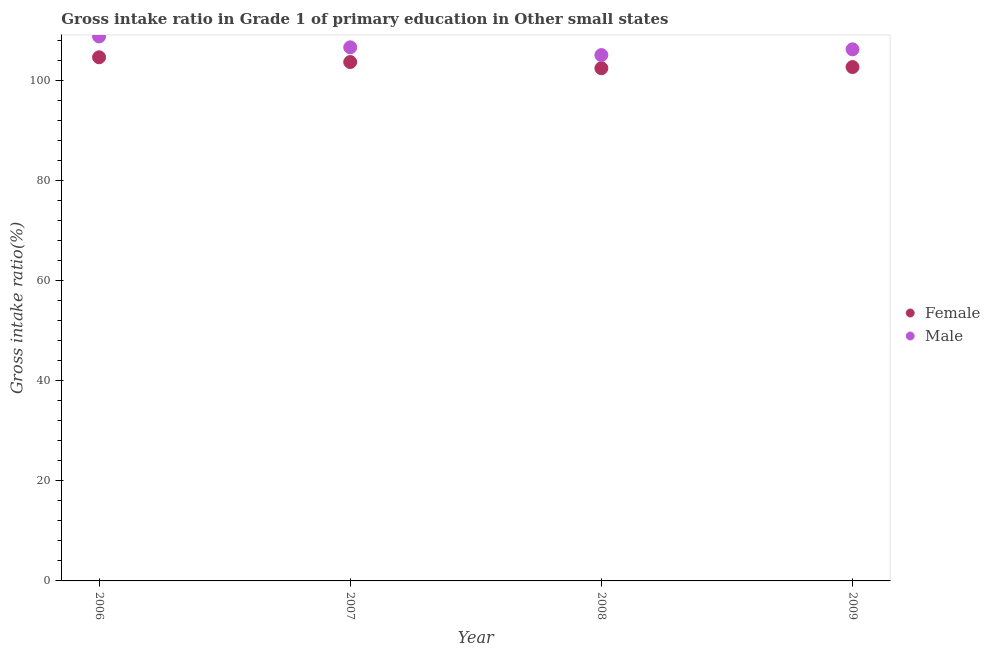How many different coloured dotlines are there?
Make the answer very short. 2. Is the number of dotlines equal to the number of legend labels?
Your answer should be very brief. Yes. What is the gross intake ratio(male) in 2009?
Give a very brief answer. 106.2. Across all years, what is the maximum gross intake ratio(female)?
Provide a succinct answer. 104.61. Across all years, what is the minimum gross intake ratio(female)?
Keep it short and to the point. 102.42. In which year was the gross intake ratio(female) minimum?
Provide a succinct answer. 2008. What is the total gross intake ratio(male) in the graph?
Offer a very short reply. 426.63. What is the difference between the gross intake ratio(female) in 2006 and that in 2009?
Ensure brevity in your answer.  1.95. What is the difference between the gross intake ratio(male) in 2007 and the gross intake ratio(female) in 2009?
Make the answer very short. 3.94. What is the average gross intake ratio(female) per year?
Provide a short and direct response. 103.34. In the year 2007, what is the difference between the gross intake ratio(male) and gross intake ratio(female)?
Give a very brief answer. 2.94. In how many years, is the gross intake ratio(male) greater than 48 %?
Provide a succinct answer. 4. What is the ratio of the gross intake ratio(male) in 2008 to that in 2009?
Give a very brief answer. 0.99. Is the difference between the gross intake ratio(female) in 2007 and 2008 greater than the difference between the gross intake ratio(male) in 2007 and 2008?
Provide a succinct answer. No. What is the difference between the highest and the second highest gross intake ratio(female)?
Your response must be concise. 0.95. What is the difference between the highest and the lowest gross intake ratio(male)?
Provide a succinct answer. 3.72. Is the gross intake ratio(female) strictly less than the gross intake ratio(male) over the years?
Your answer should be compact. Yes. How many dotlines are there?
Make the answer very short. 2. What is the difference between two consecutive major ticks on the Y-axis?
Offer a terse response. 20. Are the values on the major ticks of Y-axis written in scientific E-notation?
Your answer should be compact. No. Does the graph contain any zero values?
Ensure brevity in your answer.  No. Where does the legend appear in the graph?
Give a very brief answer. Center right. How many legend labels are there?
Provide a succinct answer. 2. How are the legend labels stacked?
Keep it short and to the point. Vertical. What is the title of the graph?
Your answer should be very brief. Gross intake ratio in Grade 1 of primary education in Other small states. What is the label or title of the X-axis?
Provide a succinct answer. Year. What is the label or title of the Y-axis?
Your response must be concise. Gross intake ratio(%). What is the Gross intake ratio(%) of Female in 2006?
Offer a very short reply. 104.61. What is the Gross intake ratio(%) of Male in 2006?
Your response must be concise. 108.77. What is the Gross intake ratio(%) of Female in 2007?
Provide a succinct answer. 103.66. What is the Gross intake ratio(%) in Male in 2007?
Your response must be concise. 106.6. What is the Gross intake ratio(%) of Female in 2008?
Provide a succinct answer. 102.42. What is the Gross intake ratio(%) in Male in 2008?
Your response must be concise. 105.05. What is the Gross intake ratio(%) in Female in 2009?
Your answer should be compact. 102.66. What is the Gross intake ratio(%) in Male in 2009?
Make the answer very short. 106.2. Across all years, what is the maximum Gross intake ratio(%) of Female?
Make the answer very short. 104.61. Across all years, what is the maximum Gross intake ratio(%) in Male?
Ensure brevity in your answer.  108.77. Across all years, what is the minimum Gross intake ratio(%) of Female?
Provide a succinct answer. 102.42. Across all years, what is the minimum Gross intake ratio(%) of Male?
Keep it short and to the point. 105.05. What is the total Gross intake ratio(%) in Female in the graph?
Provide a succinct answer. 413.36. What is the total Gross intake ratio(%) of Male in the graph?
Give a very brief answer. 426.63. What is the difference between the Gross intake ratio(%) of Female in 2006 and that in 2007?
Offer a very short reply. 0.95. What is the difference between the Gross intake ratio(%) in Male in 2006 and that in 2007?
Make the answer very short. 2.17. What is the difference between the Gross intake ratio(%) of Female in 2006 and that in 2008?
Offer a terse response. 2.19. What is the difference between the Gross intake ratio(%) of Male in 2006 and that in 2008?
Offer a very short reply. 3.72. What is the difference between the Gross intake ratio(%) of Female in 2006 and that in 2009?
Offer a very short reply. 1.95. What is the difference between the Gross intake ratio(%) in Male in 2006 and that in 2009?
Your response must be concise. 2.57. What is the difference between the Gross intake ratio(%) in Female in 2007 and that in 2008?
Your answer should be compact. 1.24. What is the difference between the Gross intake ratio(%) in Male in 2007 and that in 2008?
Offer a terse response. 1.55. What is the difference between the Gross intake ratio(%) of Male in 2007 and that in 2009?
Give a very brief answer. 0.4. What is the difference between the Gross intake ratio(%) in Female in 2008 and that in 2009?
Offer a terse response. -0.24. What is the difference between the Gross intake ratio(%) of Male in 2008 and that in 2009?
Offer a terse response. -1.15. What is the difference between the Gross intake ratio(%) of Female in 2006 and the Gross intake ratio(%) of Male in 2007?
Offer a very short reply. -1.99. What is the difference between the Gross intake ratio(%) in Female in 2006 and the Gross intake ratio(%) in Male in 2008?
Offer a very short reply. -0.44. What is the difference between the Gross intake ratio(%) in Female in 2006 and the Gross intake ratio(%) in Male in 2009?
Offer a very short reply. -1.59. What is the difference between the Gross intake ratio(%) in Female in 2007 and the Gross intake ratio(%) in Male in 2008?
Your answer should be compact. -1.39. What is the difference between the Gross intake ratio(%) in Female in 2007 and the Gross intake ratio(%) in Male in 2009?
Your answer should be very brief. -2.54. What is the difference between the Gross intake ratio(%) of Female in 2008 and the Gross intake ratio(%) of Male in 2009?
Your answer should be very brief. -3.78. What is the average Gross intake ratio(%) of Female per year?
Ensure brevity in your answer.  103.34. What is the average Gross intake ratio(%) of Male per year?
Provide a succinct answer. 106.66. In the year 2006, what is the difference between the Gross intake ratio(%) in Female and Gross intake ratio(%) in Male?
Give a very brief answer. -4.16. In the year 2007, what is the difference between the Gross intake ratio(%) in Female and Gross intake ratio(%) in Male?
Make the answer very short. -2.94. In the year 2008, what is the difference between the Gross intake ratio(%) of Female and Gross intake ratio(%) of Male?
Offer a very short reply. -2.63. In the year 2009, what is the difference between the Gross intake ratio(%) of Female and Gross intake ratio(%) of Male?
Your answer should be compact. -3.54. What is the ratio of the Gross intake ratio(%) of Female in 2006 to that in 2007?
Offer a very short reply. 1.01. What is the ratio of the Gross intake ratio(%) in Male in 2006 to that in 2007?
Ensure brevity in your answer.  1.02. What is the ratio of the Gross intake ratio(%) in Female in 2006 to that in 2008?
Keep it short and to the point. 1.02. What is the ratio of the Gross intake ratio(%) in Male in 2006 to that in 2008?
Your answer should be very brief. 1.04. What is the ratio of the Gross intake ratio(%) in Female in 2006 to that in 2009?
Keep it short and to the point. 1.02. What is the ratio of the Gross intake ratio(%) in Male in 2006 to that in 2009?
Make the answer very short. 1.02. What is the ratio of the Gross intake ratio(%) in Female in 2007 to that in 2008?
Offer a terse response. 1.01. What is the ratio of the Gross intake ratio(%) in Male in 2007 to that in 2008?
Provide a succinct answer. 1.01. What is the ratio of the Gross intake ratio(%) of Female in 2007 to that in 2009?
Offer a very short reply. 1.01. What is the ratio of the Gross intake ratio(%) of Male in 2008 to that in 2009?
Provide a short and direct response. 0.99. What is the difference between the highest and the second highest Gross intake ratio(%) in Female?
Your answer should be very brief. 0.95. What is the difference between the highest and the second highest Gross intake ratio(%) of Male?
Give a very brief answer. 2.17. What is the difference between the highest and the lowest Gross intake ratio(%) in Female?
Your answer should be compact. 2.19. What is the difference between the highest and the lowest Gross intake ratio(%) of Male?
Provide a short and direct response. 3.72. 